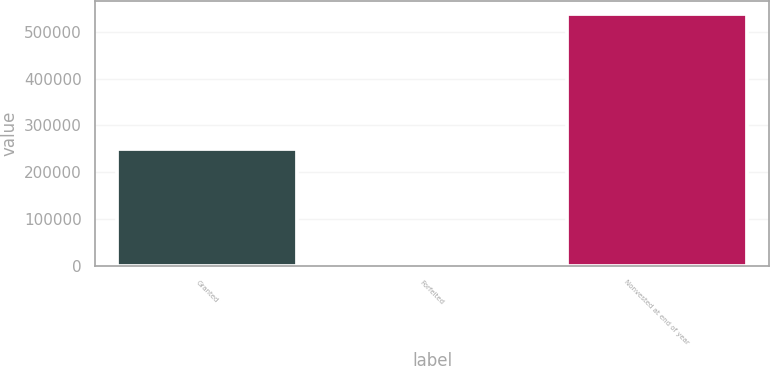Convert chart to OTSL. <chart><loc_0><loc_0><loc_500><loc_500><bar_chart><fcel>Granted<fcel>Forfeited<fcel>Nonvested at end of year<nl><fcel>248710<fcel>6540<fcel>538592<nl></chart> 